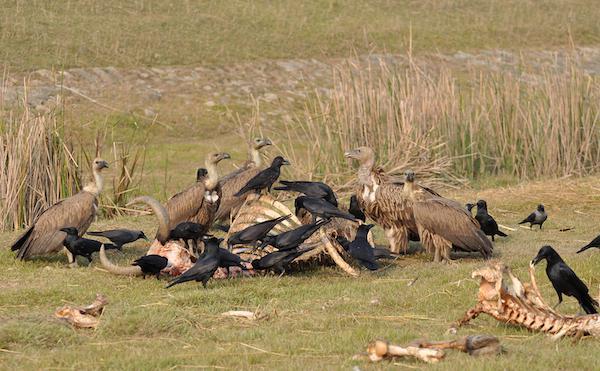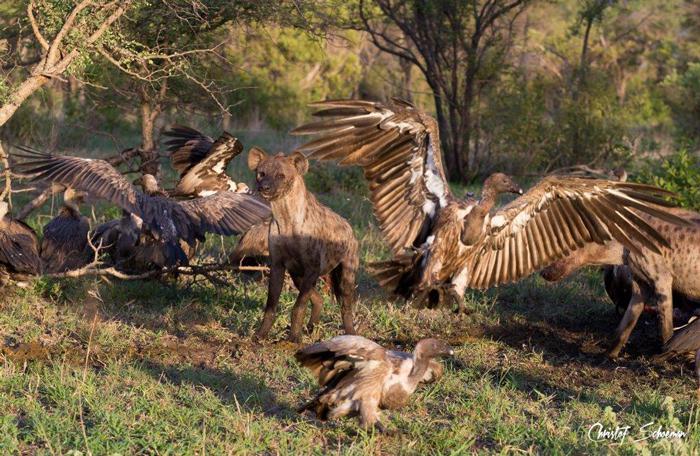The first image is the image on the left, the second image is the image on the right. Evaluate the accuracy of this statement regarding the images: "There are two kinds of bird in the image on the left.". Is it true? Answer yes or no. Yes. The first image is the image on the left, the second image is the image on the right. Assess this claim about the two images: "At least one image shows an apparently living mammal surrounded by vultures.". Correct or not? Answer yes or no. Yes. 